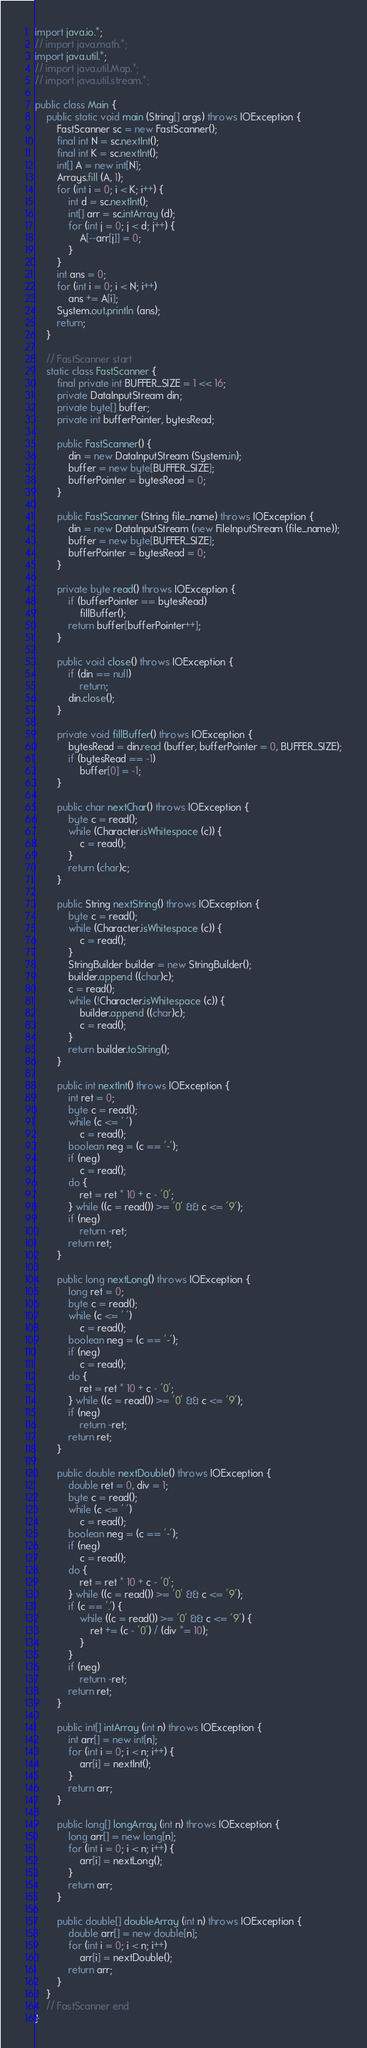Convert code to text. <code><loc_0><loc_0><loc_500><loc_500><_Java_>import java.io.*;
// import java.math.*;
import java.util.*;
// import java.util.Map.*;
// import java.util.stream.*;

public class Main {
    public static void main (String[] args) throws IOException {
        FastScanner sc = new FastScanner();
        final int N = sc.nextInt();
        final int K = sc.nextInt();
        int[] A = new int[N];
        Arrays.fill (A, 1);
        for (int i = 0; i < K; i++) {
            int d = sc.nextInt();
            int[] arr = sc.intArray (d);
            for (int j = 0; j < d; j++) {
                A[--arr[j]] = 0;
            }
        }
        int ans = 0;
        for (int i = 0; i < N; i++)
            ans += A[i];
        System.out.println (ans);
        return;
    }

    // FastScanner start
    static class FastScanner {
        final private int BUFFER_SIZE = 1 << 16;
        private DataInputStream din;
        private byte[] buffer;
        private int bufferPointer, bytesRead;

        public FastScanner() {
            din = new DataInputStream (System.in);
            buffer = new byte[BUFFER_SIZE];
            bufferPointer = bytesRead = 0;
        }

        public FastScanner (String file_name) throws IOException {
            din = new DataInputStream (new FileInputStream (file_name));
            buffer = new byte[BUFFER_SIZE];
            bufferPointer = bytesRead = 0;
        }

        private byte read() throws IOException {
            if (bufferPointer == bytesRead)
                fillBuffer();
            return buffer[bufferPointer++];
        }

        public void close() throws IOException {
            if (din == null)
                return;
            din.close();
        }

        private void fillBuffer() throws IOException {
            bytesRead = din.read (buffer, bufferPointer = 0, BUFFER_SIZE);
            if (bytesRead == -1)
                buffer[0] = -1;
        }

        public char nextChar() throws IOException {
            byte c = read();
            while (Character.isWhitespace (c)) {
                c = read();
            }
            return (char)c;
        }

        public String nextString() throws IOException {
            byte c = read();
            while (Character.isWhitespace (c)) {
                c = read();
            }
            StringBuilder builder = new StringBuilder();
            builder.append ((char)c);
            c = read();
            while (!Character.isWhitespace (c)) {
                builder.append ((char)c);
                c = read();
            }
            return builder.toString();
        }

        public int nextInt() throws IOException {
            int ret = 0;
            byte c = read();
            while (c <= ' ')
                c = read();
            boolean neg = (c == '-');
            if (neg)
                c = read();
            do {
                ret = ret * 10 + c - '0';
            } while ((c = read()) >= '0' && c <= '9');
            if (neg)
                return -ret;
            return ret;
        }

        public long nextLong() throws IOException {
            long ret = 0;
            byte c = read();
            while (c <= ' ')
                c = read();
            boolean neg = (c == '-');
            if (neg)
                c = read();
            do {
                ret = ret * 10 + c - '0';
            } while ((c = read()) >= '0' && c <= '9');
            if (neg)
                return -ret;
            return ret;
        }

        public double nextDouble() throws IOException {
            double ret = 0, div = 1;
            byte c = read();
            while (c <= ' ')
                c = read();
            boolean neg = (c == '-');
            if (neg)
                c = read();
            do {
                ret = ret * 10 + c - '0';
            } while ((c = read()) >= '0' && c <= '9');
            if (c == '.') {
                while ((c = read()) >= '0' && c <= '9') {
                    ret += (c - '0') / (div *= 10);
                }
            }
            if (neg)
                return -ret;
            return ret;
        }

        public int[] intArray (int n) throws IOException {
            int arr[] = new int[n];
            for (int i = 0; i < n; i++) {
                arr[i] = nextInt();
            }
            return arr;
        }

        public long[] longArray (int n) throws IOException {
            long arr[] = new long[n];
            for (int i = 0; i < n; i++) {
                arr[i] = nextLong();
            }
            return arr;
        }

        public double[] doubleArray (int n) throws IOException {
            double arr[] = new double[n];
            for (int i = 0; i < n; i++)
                arr[i] = nextDouble();
            return arr;
        }
    }
    // FastScanner end
}</code> 